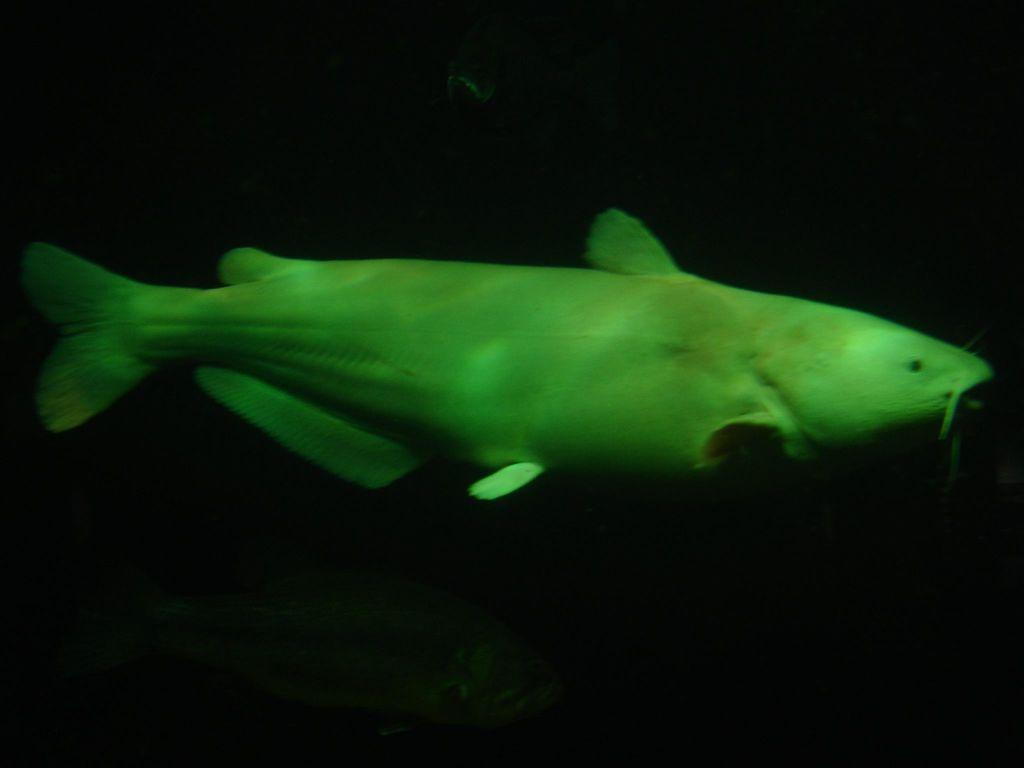What is the main subject of the image? There is a fish swimming in the image. What is the environment in which the fish is swimming? The fish is in water. Can you describe any specific visual effects in the image? There is a green reflection in the image. What is the color of the background in the image? The background of the image is black. What type of boundary can be seen in the image? There is no boundary present in the image; it features a fish swimming in water with a black background and a green reflection. Can you describe the flight pattern of the fish in the image? Fish do not fly, so there is no flight pattern to describe in the image. 